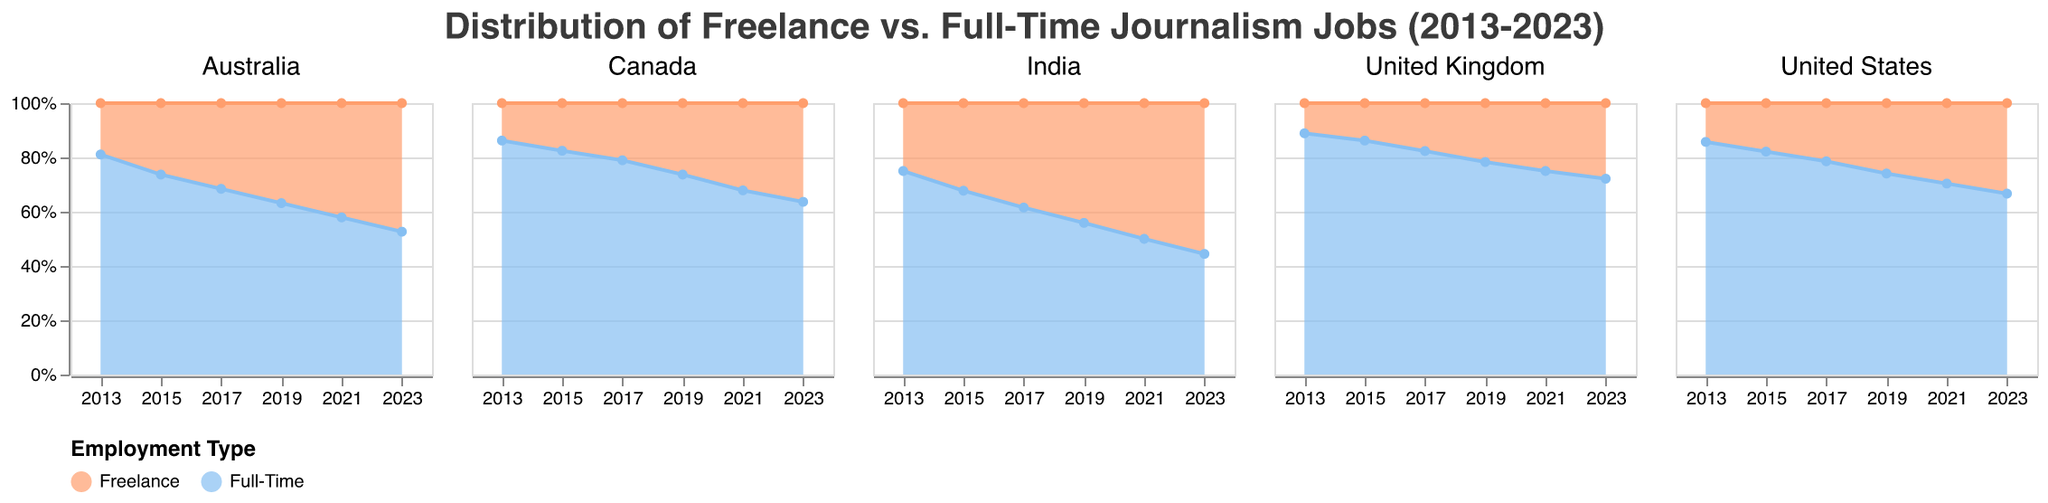What is the title of the figure? The title is often displayed at the top of the figure and reflects the overall subject of the chart. In this case, it describes the topic of the chart.
Answer: Distribution of Freelance vs. Full-Time Journalism Jobs (2013-2023) How are freelance journalism jobs trending in India from 2013 to 2023? Observing the area corresponding to freelance jobs in India's subplot, the area expands over time, indicating an increase.
Answer: Increasing In 2023, which country has the most full-time journalism jobs? In 2023, locate the full-time areas in each country's subplot and compare their heights. The United States has the highest area.
Answer: United States By how much did freelance journalism jobs increase in Canada from 2013 to 2023? Compare the y-values for freelance jobs in Canada in 2013 and 2023. Freelance jobs increased from 800 to 2000. Therefore, the increase is 2000 - 800.
Answer: 1200 In which year did India have an equal number of freelance and full-time journalism jobs? Look for the year in India's subplot where the areas of freelance and full-time jobs are equal. This occurs in 2021.
Answer: 2021 What is the overall trend for full-time journalism jobs in the United Kingdom from 2013 to 2023? Observing the area corresponding to full-time jobs in the United Kingdom's subplot, the area decreases over time, indicating a downward trend.
Answer: Decreasing Which country sees the smallest number of jobs (freelance or full-time) in 2019? Checking each subplot for 2019, Australia has the smallest number of full-time jobs of 2400, which is the smallest value in 2019 among all countries.
Answer: Australia What is the color used to represent freelance jobs? The color can be identified by the legend of the chart, indicating freelance jobs.
Answer: Orange How do full-time journalism jobs in Australia change from 2013 to 2023? Observing the area corresponding to full-time jobs in Australia's subplot from 2013 to 2023, it shows a decreasing pattern.
Answer: Decreasing 